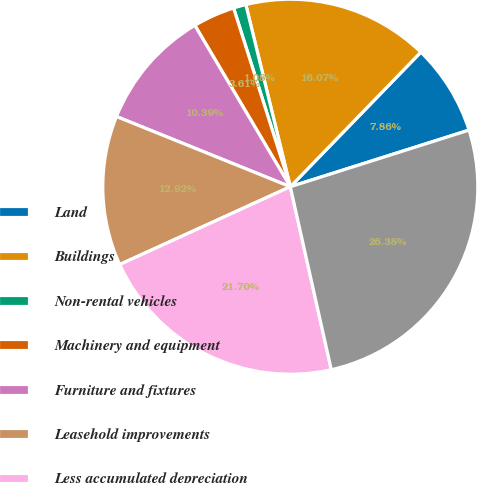Convert chart to OTSL. <chart><loc_0><loc_0><loc_500><loc_500><pie_chart><fcel>Land<fcel>Buildings<fcel>Non-rental vehicles<fcel>Machinery and equipment<fcel>Furniture and fixtures<fcel>Leasehold improvements<fcel>Less accumulated depreciation<fcel>Property and equipment net<nl><fcel>7.86%<fcel>16.07%<fcel>1.08%<fcel>3.61%<fcel>10.39%<fcel>12.92%<fcel>21.7%<fcel>26.38%<nl></chart> 